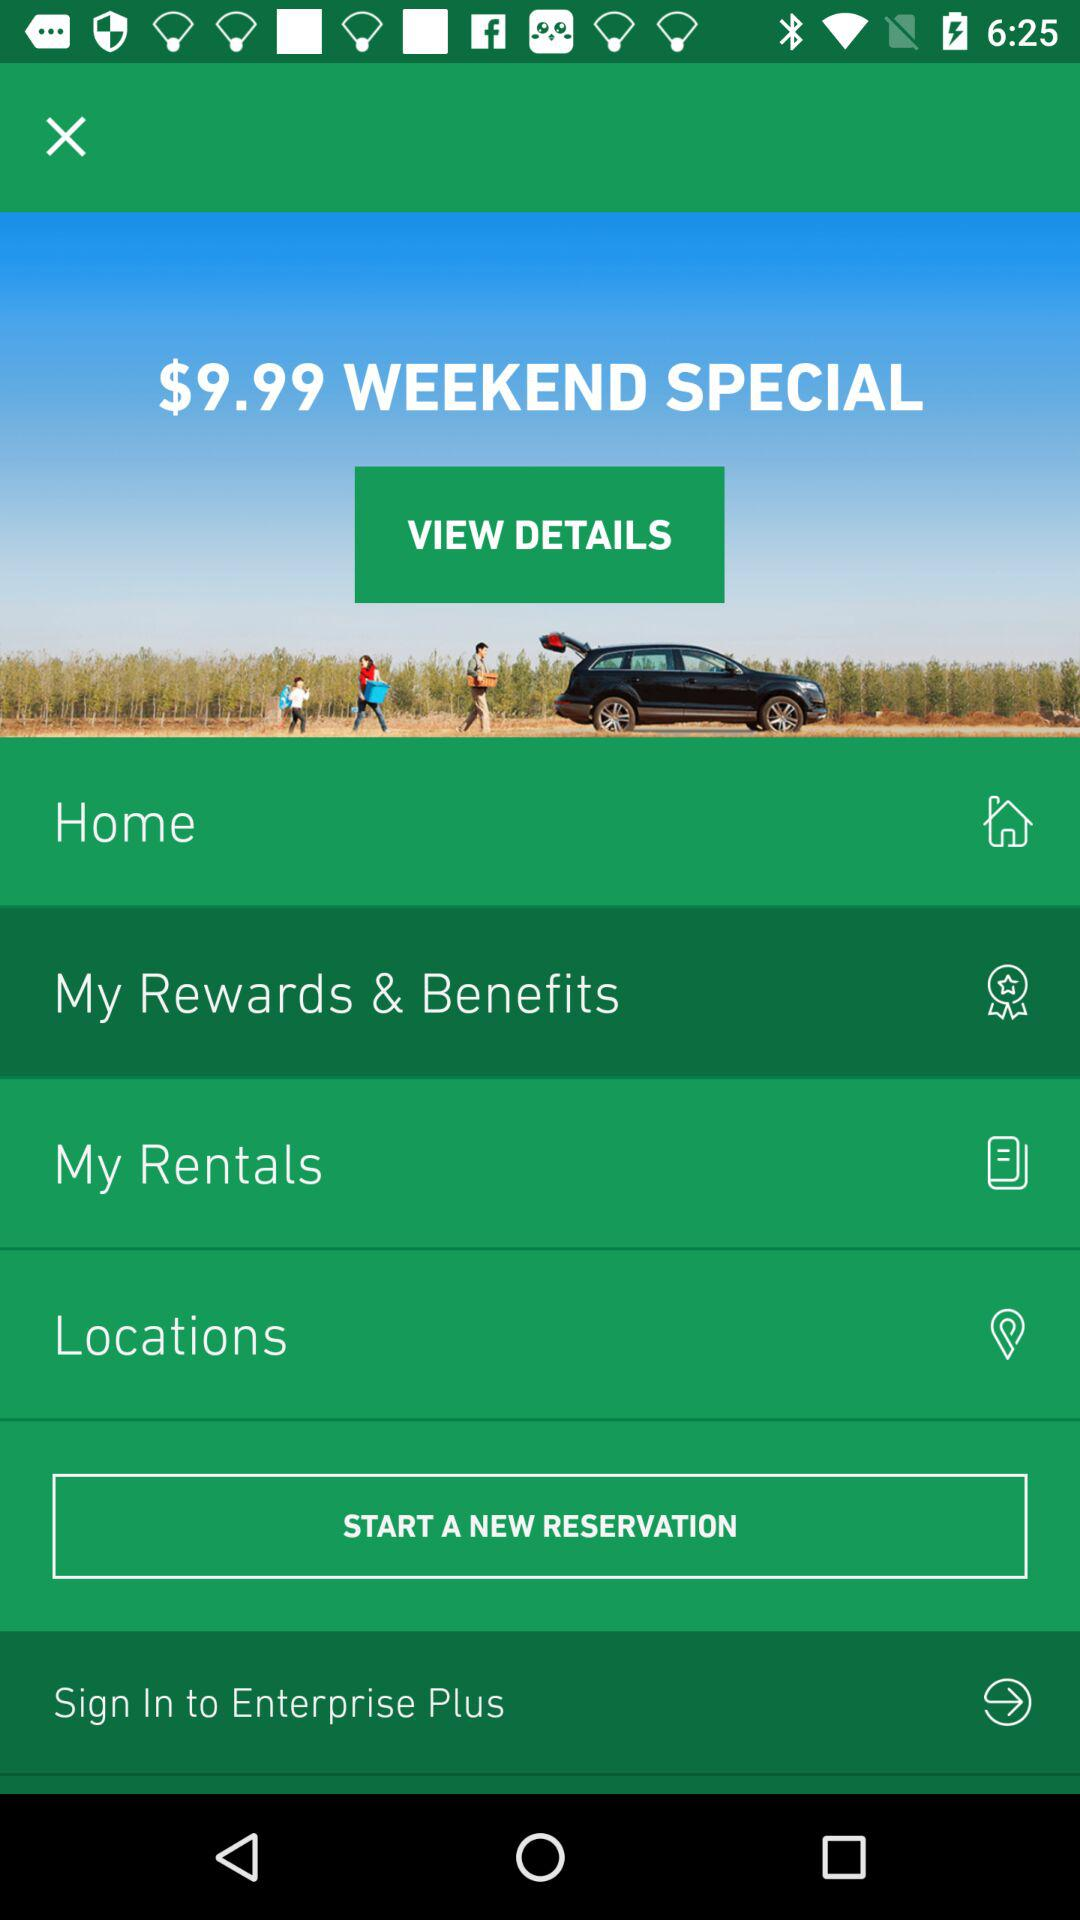What is the given cost? The given cost is $9.99. 